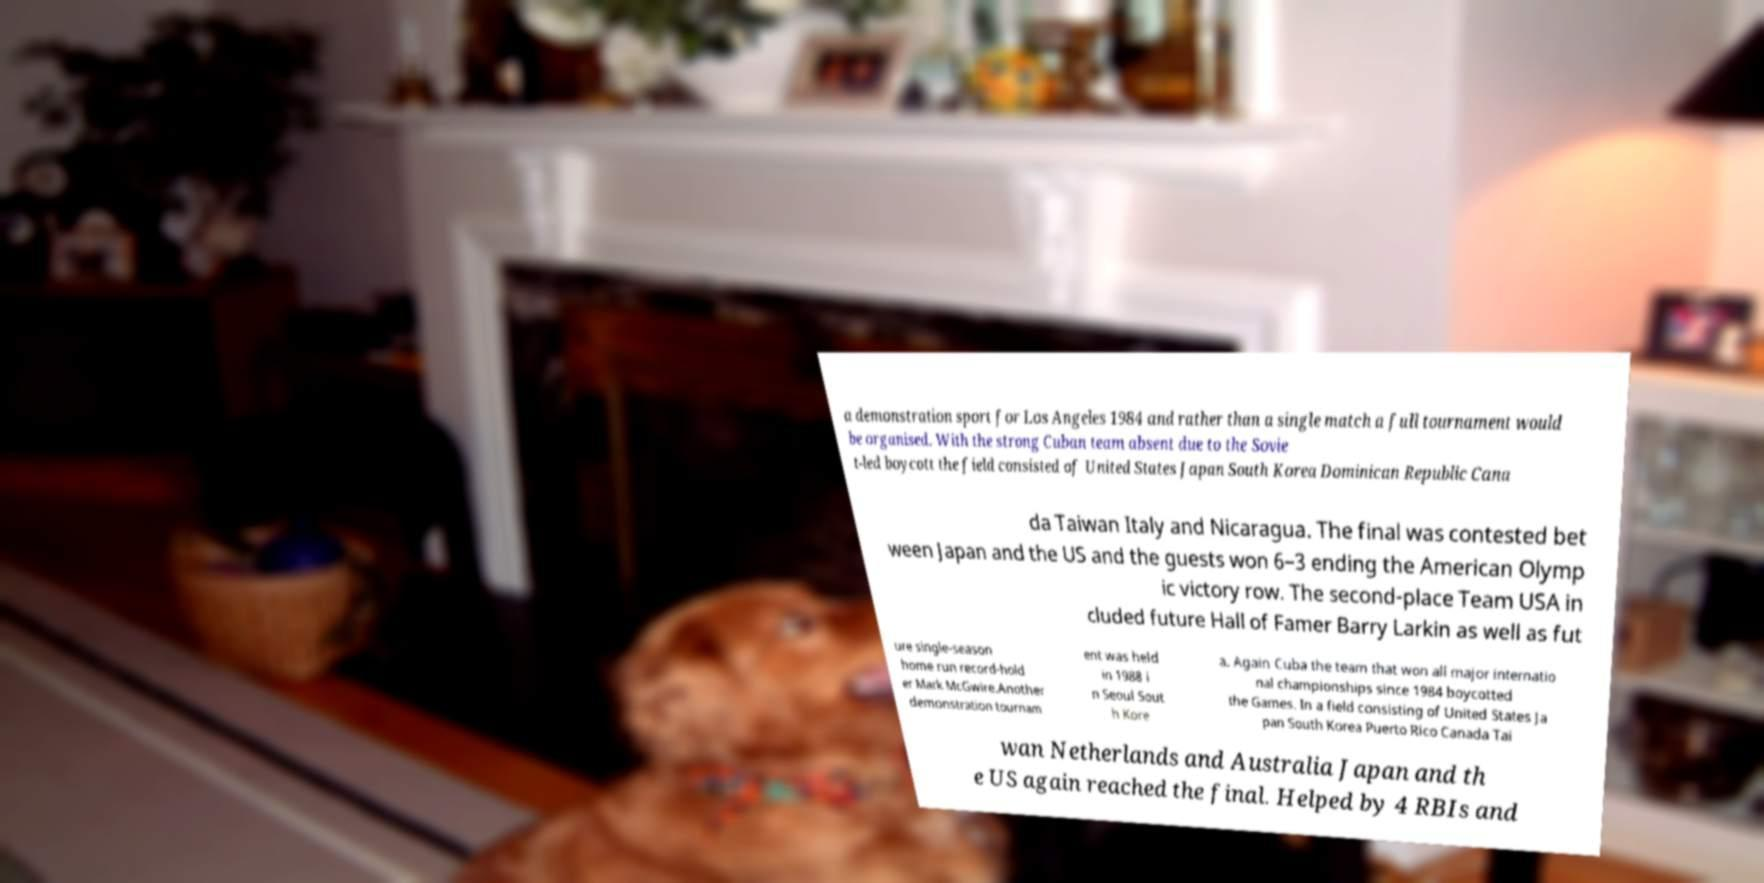Can you read and provide the text displayed in the image?This photo seems to have some interesting text. Can you extract and type it out for me? a demonstration sport for Los Angeles 1984 and rather than a single match a full tournament would be organised. With the strong Cuban team absent due to the Sovie t-led boycott the field consisted of United States Japan South Korea Dominican Republic Cana da Taiwan Italy and Nicaragua. The final was contested bet ween Japan and the US and the guests won 6–3 ending the American Olymp ic victory row. The second-place Team USA in cluded future Hall of Famer Barry Larkin as well as fut ure single-season home run record-hold er Mark McGwire.Another demonstration tournam ent was held in 1988 i n Seoul Sout h Kore a. Again Cuba the team that won all major internatio nal championships since 1984 boycotted the Games. In a field consisting of United States Ja pan South Korea Puerto Rico Canada Tai wan Netherlands and Australia Japan and th e US again reached the final. Helped by 4 RBIs and 